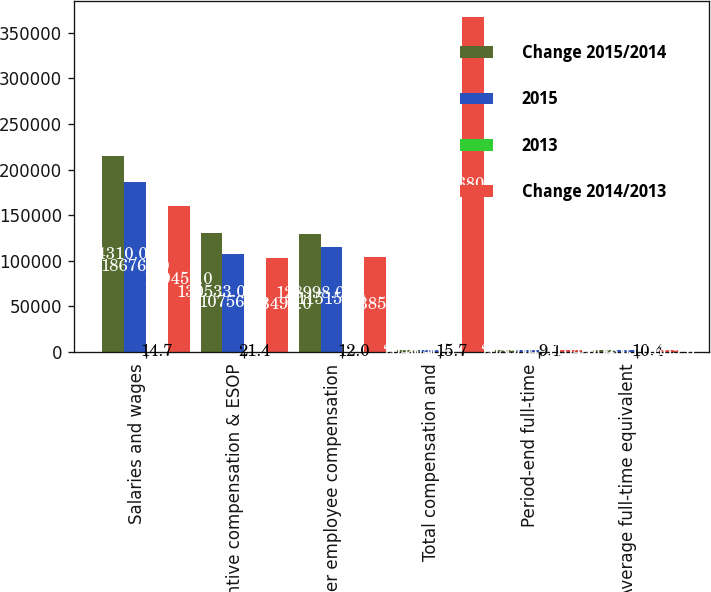<chart> <loc_0><loc_0><loc_500><loc_500><stacked_bar_chart><ecel><fcel>Salaries and wages<fcel>Incentive compensation & ESOP<fcel>Other employee compensation<fcel>Total compensation and<fcel>Period-end full-time<fcel>Average full-time equivalent<nl><fcel>Change 2015/2014<fcel>214310<fcel>130533<fcel>128998<fcel>2046.5<fcel>2089<fcel>2004<nl><fcel>2015<fcel>186763<fcel>107564<fcel>115159<fcel>2046.5<fcel>1914<fcel>1815<nl><fcel>2013<fcel>14.7<fcel>21.4<fcel>12<fcel>15.7<fcel>9.1<fcel>10.4<nl><fcel>Change 2014/2013<fcel>159455<fcel>103494<fcel>103852<fcel>366801<fcel>1704<fcel>1669<nl></chart> 